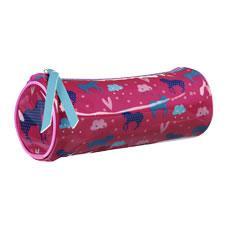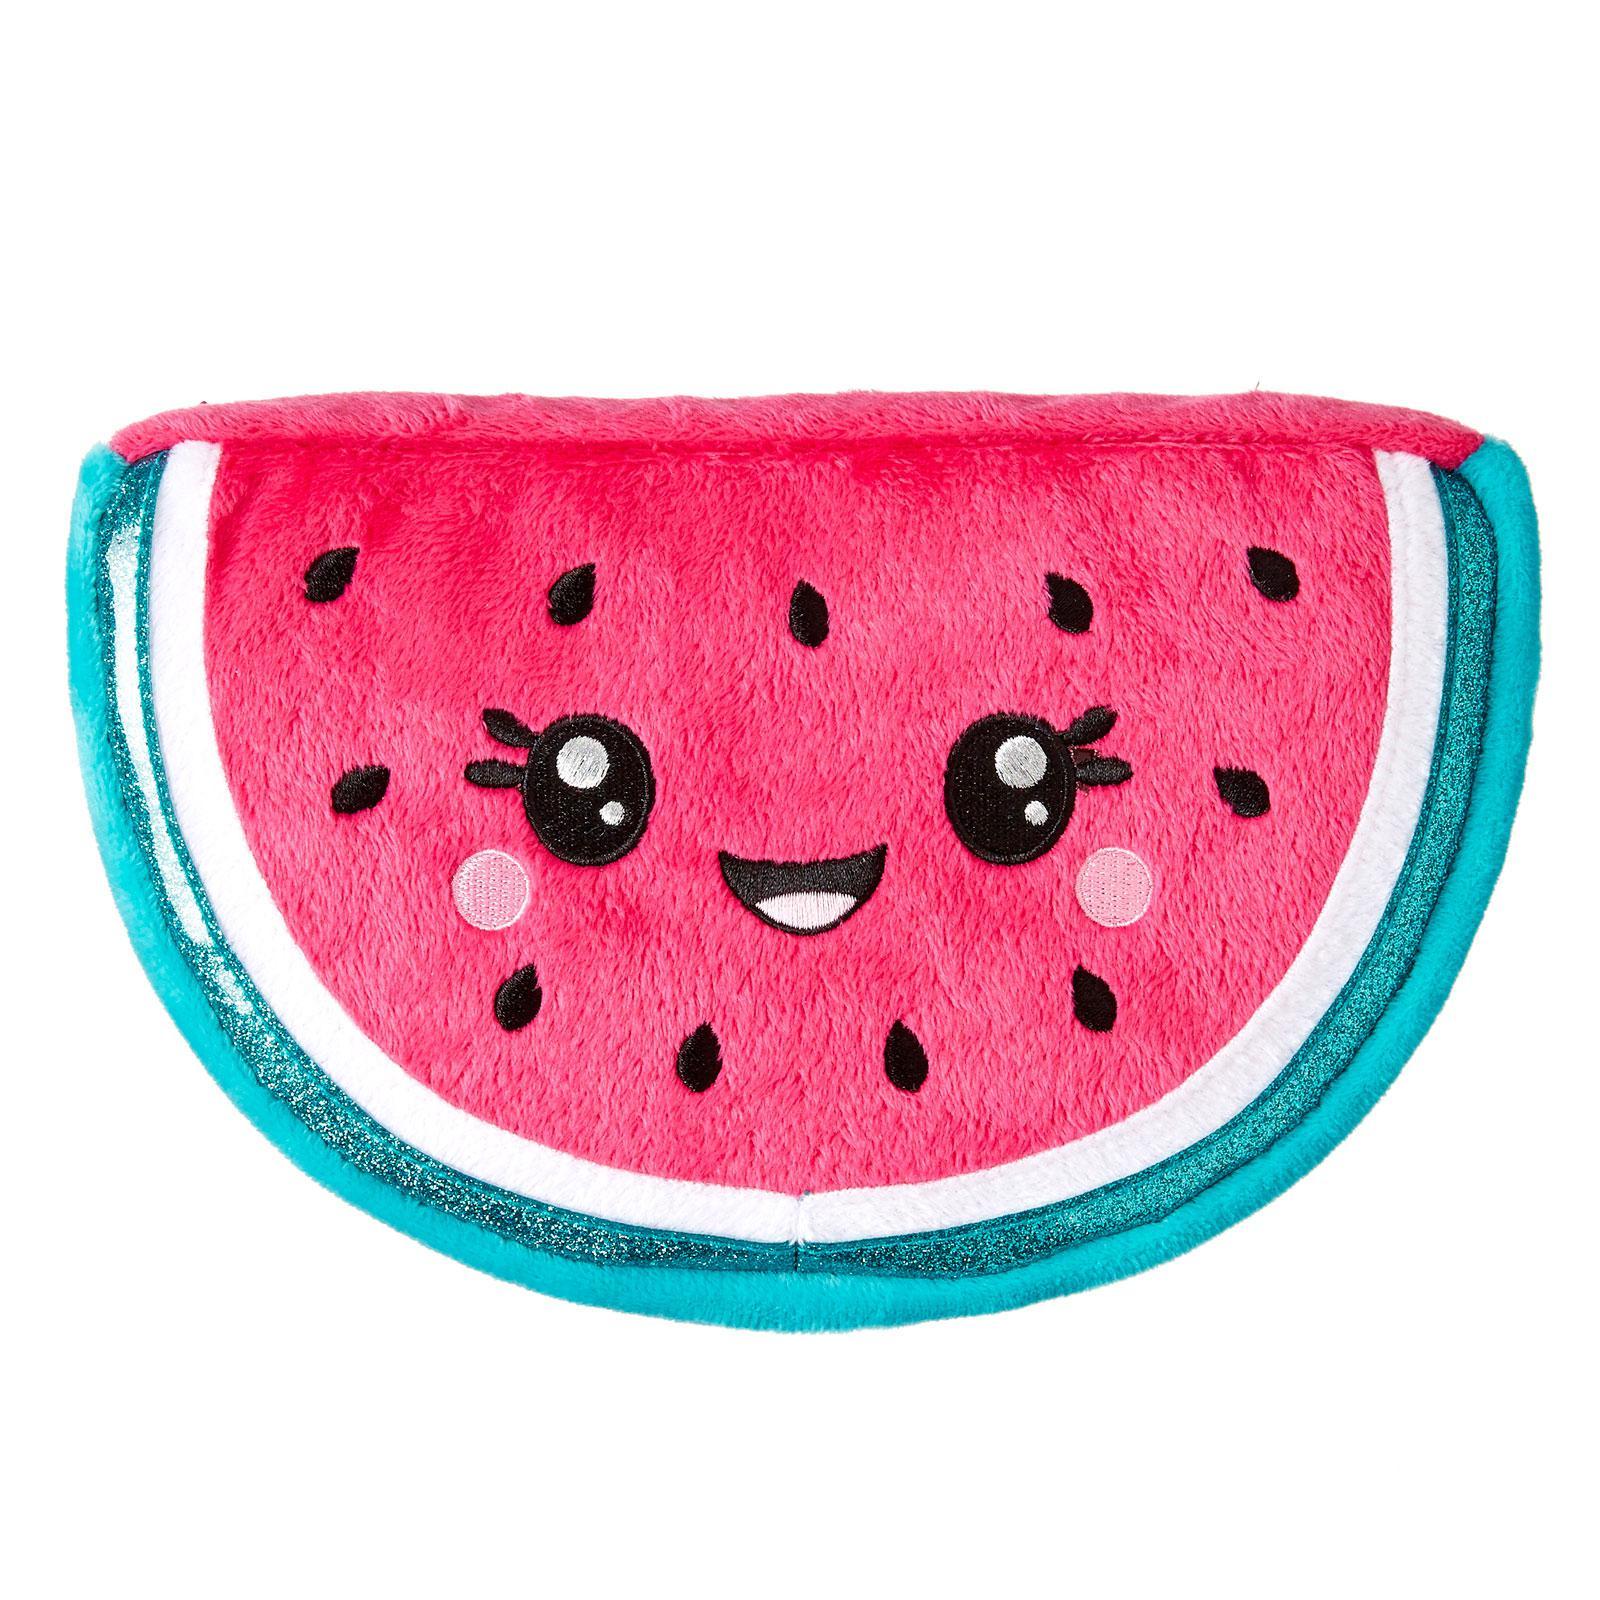The first image is the image on the left, the second image is the image on the right. Considering the images on both sides, is "One of the cases looks like a watermelon slice with a turquoise-blue rind." valid? Answer yes or no. Yes. The first image is the image on the left, the second image is the image on the right. Assess this claim about the two images: "The bag in the image on the left is shaped like a watermelon.". Correct or not? Answer yes or no. No. 